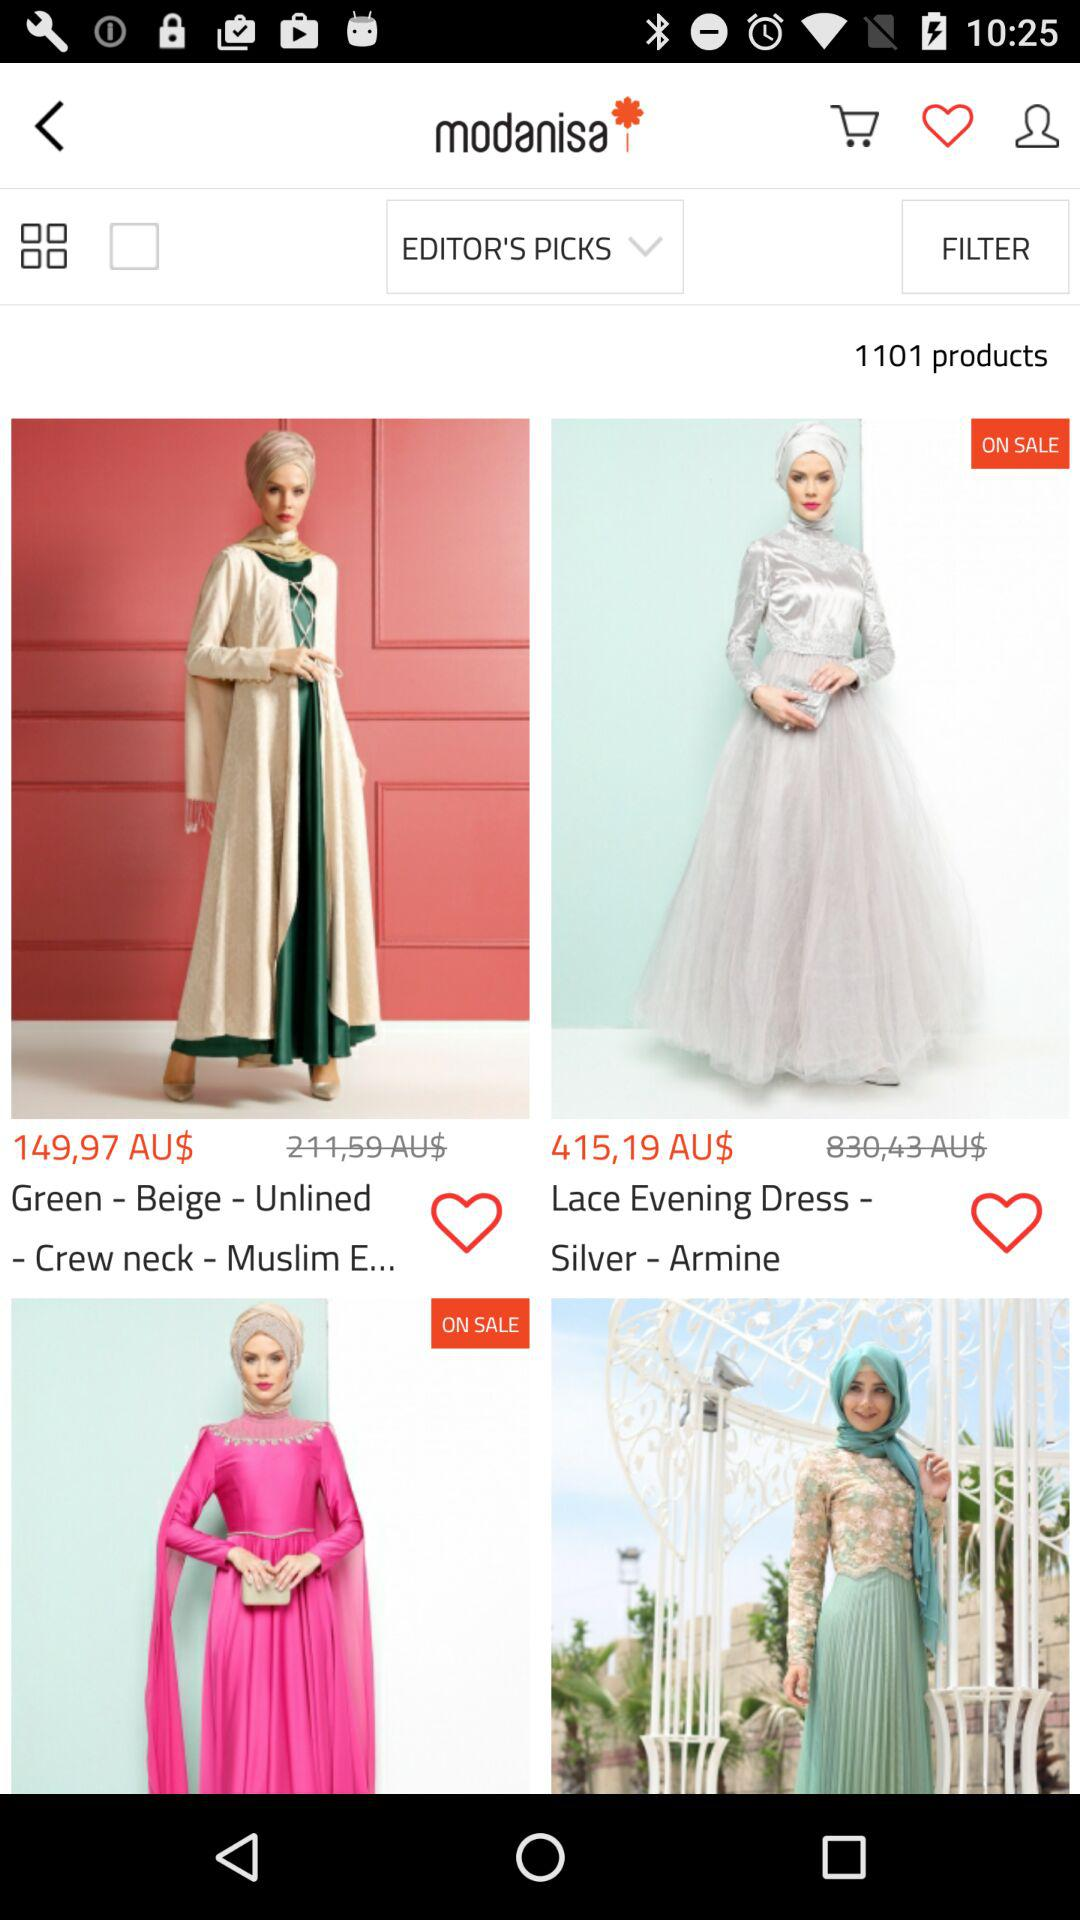What is the application name? The application name is "modanisa". 